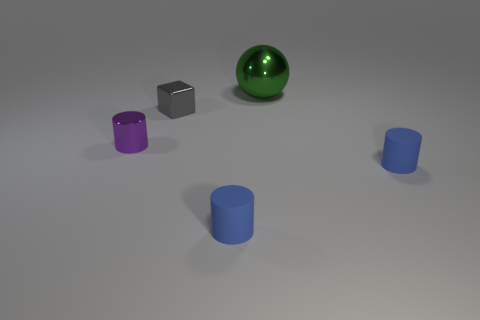There is a matte cylinder that is on the right side of the matte cylinder to the left of the big green ball on the right side of the gray block; what is its size?
Provide a short and direct response. Small. What is the material of the large green thing?
Keep it short and to the point. Metal. There is a small purple metal thing; is it the same shape as the small metal thing that is behind the small metallic cylinder?
Make the answer very short. No. There is a blue cylinder to the left of the tiny blue matte thing that is behind the tiny blue rubber cylinder that is to the left of the big sphere; what is its material?
Provide a short and direct response. Rubber. What number of small blue rubber cubes are there?
Ensure brevity in your answer.  0. How many brown objects are either shiny things or small things?
Your answer should be compact. 0. How many other objects are there of the same shape as the small purple thing?
Your answer should be very brief. 2. Is the color of the small object on the right side of the large object the same as the small shiny object behind the tiny purple cylinder?
Make the answer very short. No. What number of large objects are gray metallic objects or green spheres?
Your answer should be very brief. 1. Are there any other things that are the same size as the green shiny sphere?
Ensure brevity in your answer.  No. 